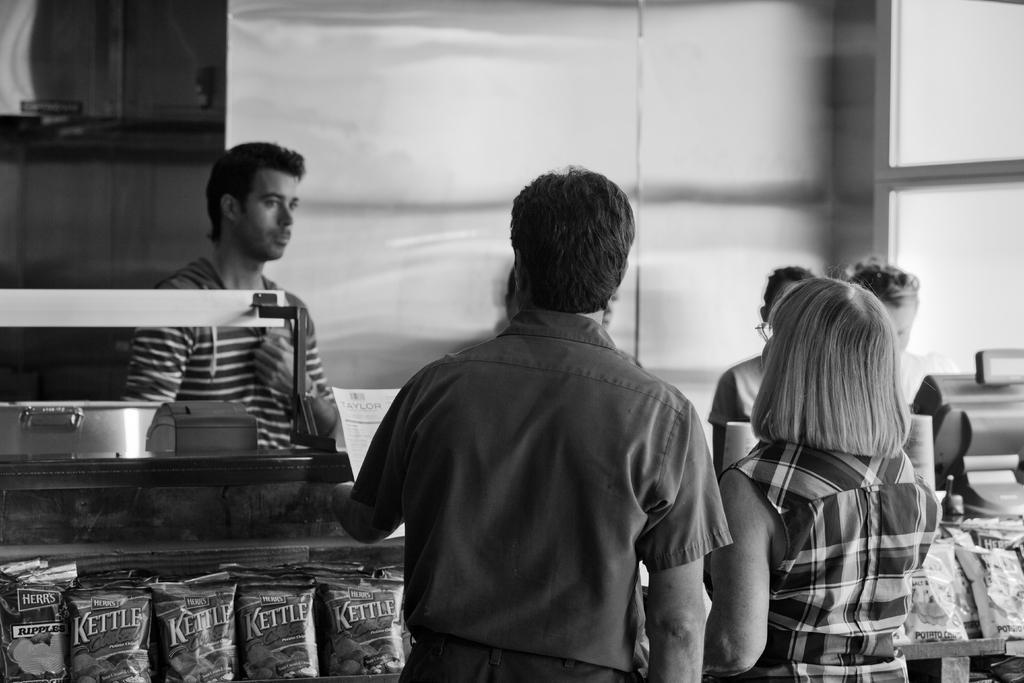Please provide a concise description of this image. In the picture we can see some people are standing near the desk and in the desk we can see some edible packs from the glass and some person standing near it. 